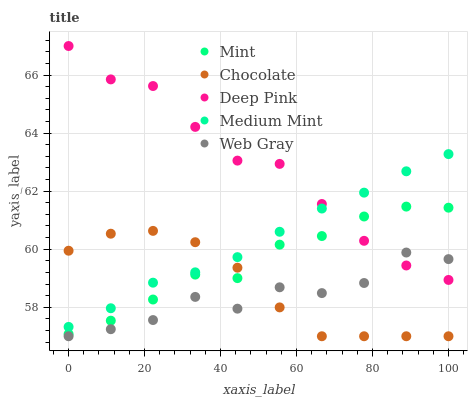Does Web Gray have the minimum area under the curve?
Answer yes or no. Yes. Does Deep Pink have the maximum area under the curve?
Answer yes or no. Yes. Does Mint have the minimum area under the curve?
Answer yes or no. No. Does Mint have the maximum area under the curve?
Answer yes or no. No. Is Medium Mint the smoothest?
Answer yes or no. Yes. Is Web Gray the roughest?
Answer yes or no. Yes. Is Deep Pink the smoothest?
Answer yes or no. No. Is Deep Pink the roughest?
Answer yes or no. No. Does Web Gray have the lowest value?
Answer yes or no. Yes. Does Mint have the lowest value?
Answer yes or no. No. Does Deep Pink have the highest value?
Answer yes or no. Yes. Does Mint have the highest value?
Answer yes or no. No. Is Web Gray less than Medium Mint?
Answer yes or no. Yes. Is Mint greater than Web Gray?
Answer yes or no. Yes. Does Chocolate intersect Medium Mint?
Answer yes or no. Yes. Is Chocolate less than Medium Mint?
Answer yes or no. No. Is Chocolate greater than Medium Mint?
Answer yes or no. No. Does Web Gray intersect Medium Mint?
Answer yes or no. No. 